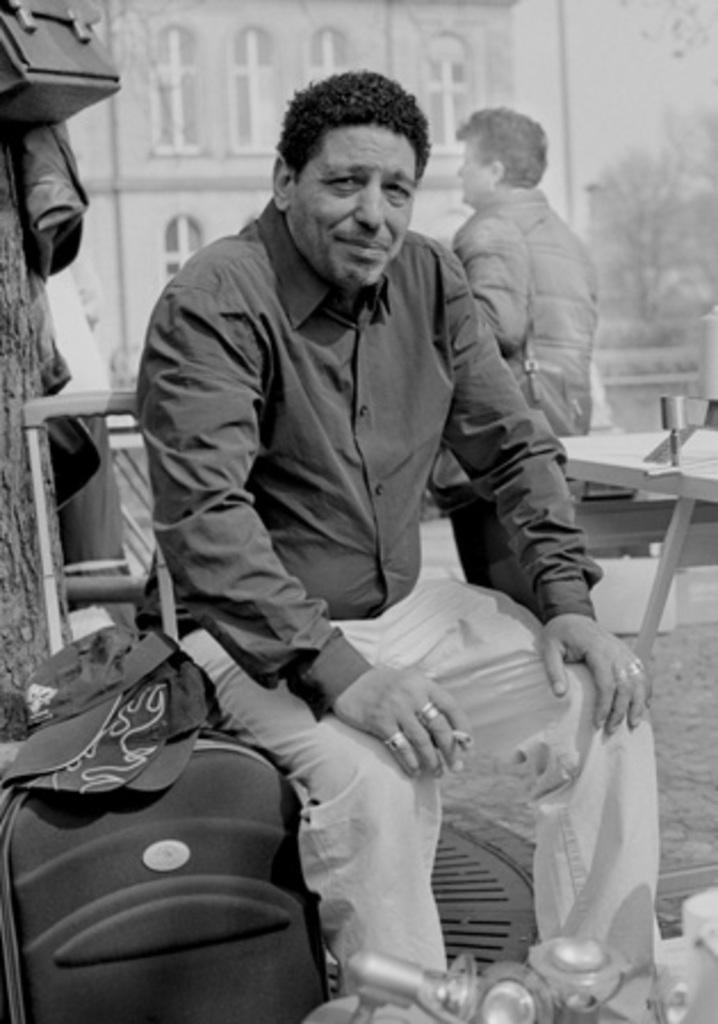Describe this image in one or two sentences. In this image there is a man sitting in chair, and beside him there is a trolley with hats , and at back ground there is bag , jacket attached to a tree, building , another person standing , another table ,tree, sky. 